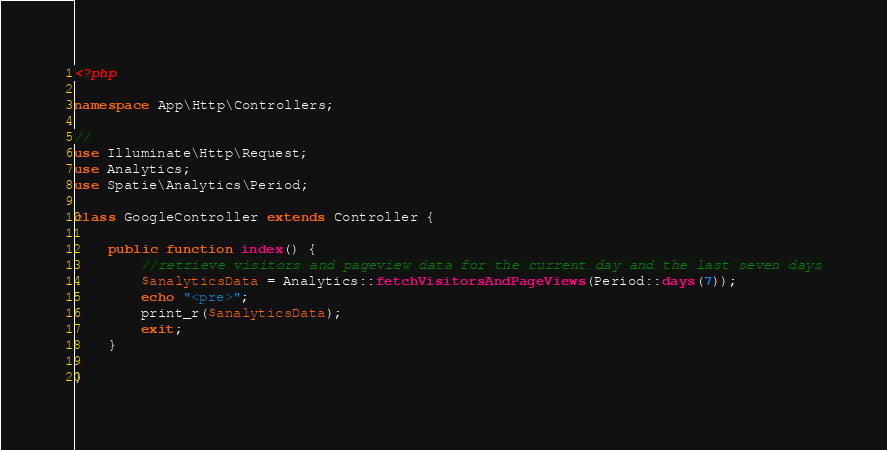<code> <loc_0><loc_0><loc_500><loc_500><_PHP_><?php

namespace App\Http\Controllers;

//
use Illuminate\Http\Request;
use Analytics;
use Spatie\Analytics\Period;

class GoogleController extends Controller {

    public function index() {
        //retrieve visitors and pageview data for the current day and the last seven days
        $analyticsData = Analytics::fetchVisitorsAndPageViews(Period::days(7));
        echo "<pre>";
        print_r($analyticsData);
        exit;
    }

}
</code> 